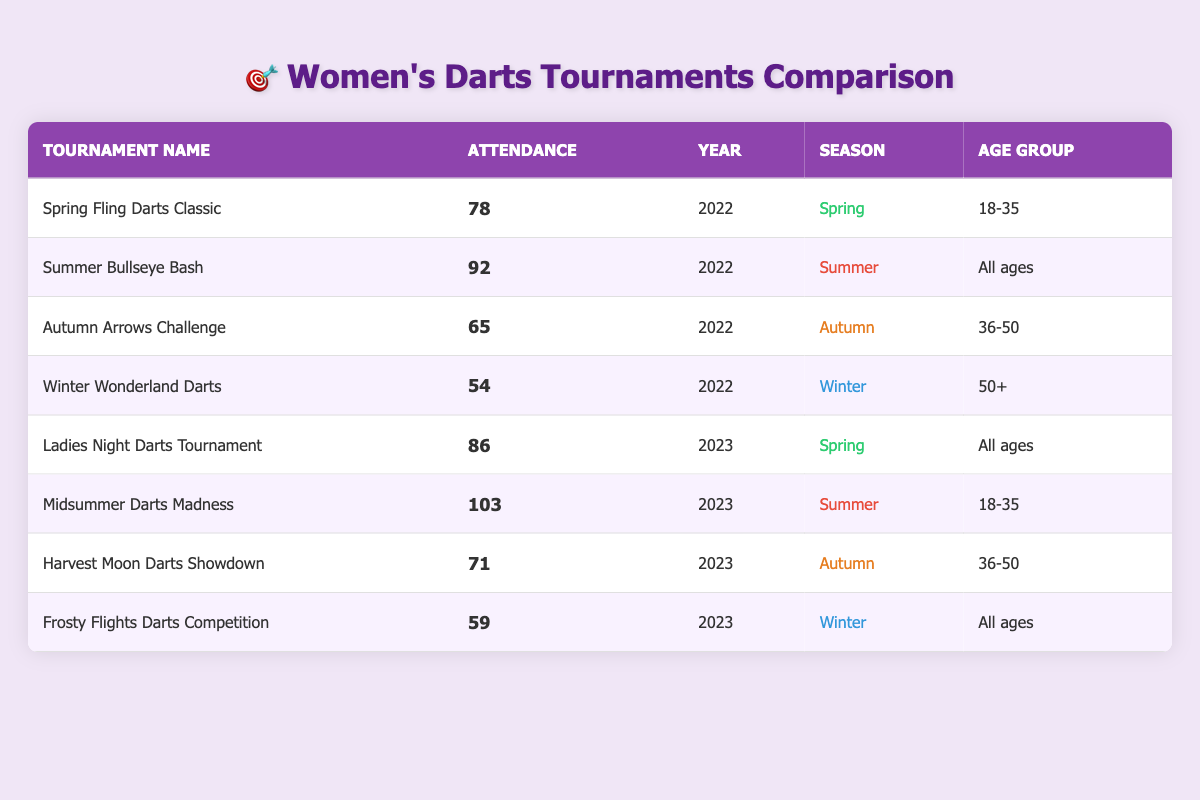What was the highest attendance in 2023? The table indicates that the attendance for Midsummer Darts Madness in 2023 was 103, which is the highest value on the list for that year.
Answer: 103 Which tournament had the least attendance in 2022? Looking at the attendance values for the year 2022, Winter Wonderland Darts had the least attendance of 54 compared to the other tournaments listed for that year.
Answer: 54 What is the average attendance for tournaments in the Summer season? The attendance for the Summer tournaments are 92 (Summer Bullseye Bash) and 103 (Midsummer Darts Madness). Summing these gives 195, and with 2 tournaments, the average is 195/2 = 97.5.
Answer: 97.5 Is there a tournament in 2022 with an attendance greater than 80? Yes, both the Spring Fling Darts Classic (78) and Summer Bullseye Bash (92) are listed, and since 92 is greater than 80, the answer is yes.
Answer: Yes How many tournaments in 2023 had attendance of 70 or more? In 2023, the tournaments are Ladies Night Darts Tournament (86), Midsummer Darts Madness (103), and Harvest Moon Darts Showdown (71). Counting those, there are 3 tournaments with attendance of 70 or more.
Answer: 3 What was the attendance difference between the Autumn Arrows Challenge 2022 and Harvest Moon Darts Showdown 2023? The attendance for Autumn Arrows Challenge in 2022 was 65, and for Harvest Moon Darts Showdown in 2023 it was 71. The difference is 71 - 65 = 6.
Answer: 6 Which age group had the highest attendance in 2023? Midsummer Darts Madness (103) and Ladies Night Darts Tournament (86) are both for younger participants (18-35 and All ages). The highest attendance is from Midsummer Darts Madness, so it was for 18-35 age group.
Answer: 18-35 Did the Winter tournament in 2023 have higher attendance than the Winter tournament in 2022? The attendance for Frosty Flights Darts Competition in 2023 was 59, while Winter Wonderland Darts in 2022 had 54. Comparing these two, 59 is greater than 54, thus the answer is yes.
Answer: Yes 